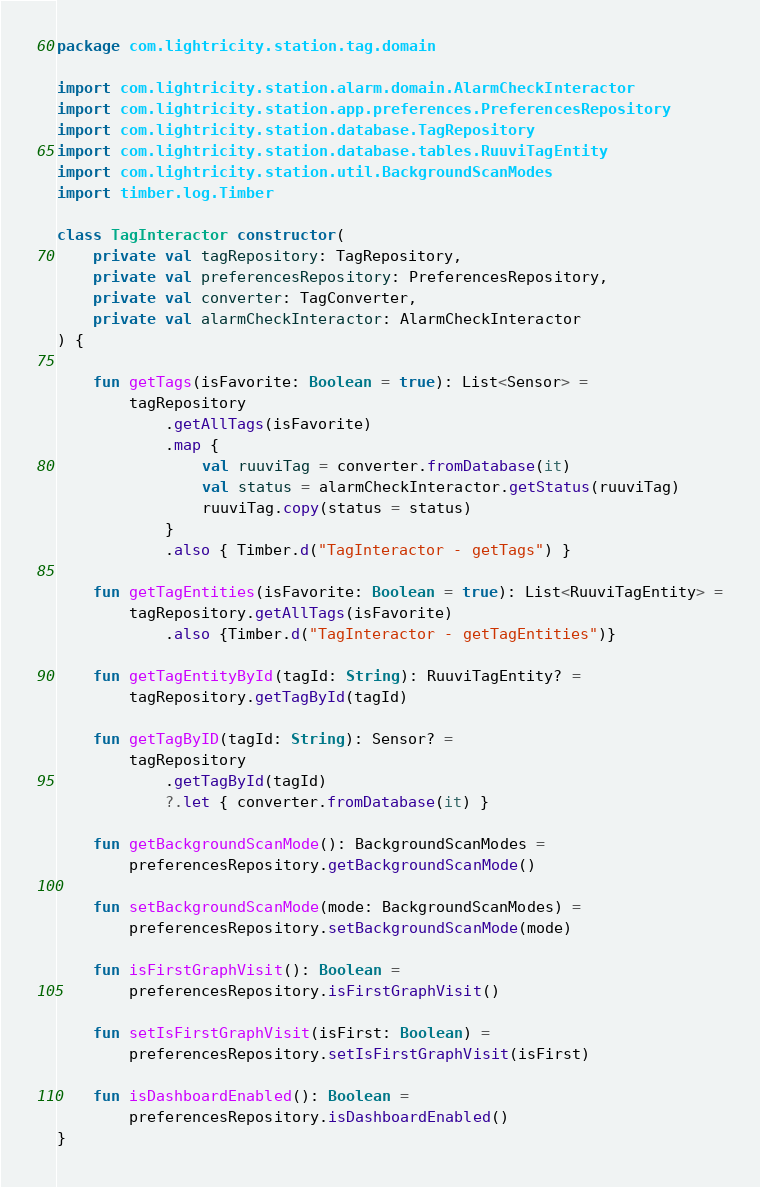Convert code to text. <code><loc_0><loc_0><loc_500><loc_500><_Kotlin_>package com.lightricity.station.tag.domain

import com.lightricity.station.alarm.domain.AlarmCheckInteractor
import com.lightricity.station.app.preferences.PreferencesRepository
import com.lightricity.station.database.TagRepository
import com.lightricity.station.database.tables.RuuviTagEntity
import com.lightricity.station.util.BackgroundScanModes
import timber.log.Timber

class TagInteractor constructor(
    private val tagRepository: TagRepository,
    private val preferencesRepository: PreferencesRepository,
    private val converter: TagConverter,
    private val alarmCheckInteractor: AlarmCheckInteractor
) {

    fun getTags(isFavorite: Boolean = true): List<Sensor> =
        tagRepository
            .getAllTags(isFavorite)
            .map {
                val ruuviTag = converter.fromDatabase(it)
                val status = alarmCheckInteractor.getStatus(ruuviTag)
                ruuviTag.copy(status = status)
            }
            .also { Timber.d("TagInteractor - getTags") }

    fun getTagEntities(isFavorite: Boolean = true): List<RuuviTagEntity> =
        tagRepository.getAllTags(isFavorite)
            .also {Timber.d("TagInteractor - getTagEntities")}

    fun getTagEntityById(tagId: String): RuuviTagEntity? =
        tagRepository.getTagById(tagId)

    fun getTagByID(tagId: String): Sensor? =
        tagRepository
            .getTagById(tagId)
            ?.let { converter.fromDatabase(it) }

    fun getBackgroundScanMode(): BackgroundScanModes =
        preferencesRepository.getBackgroundScanMode()

    fun setBackgroundScanMode(mode: BackgroundScanModes) =
        preferencesRepository.setBackgroundScanMode(mode)

    fun isFirstGraphVisit(): Boolean =
        preferencesRepository.isFirstGraphVisit()

    fun setIsFirstGraphVisit(isFirst: Boolean) =
        preferencesRepository.setIsFirstGraphVisit(isFirst)

    fun isDashboardEnabled(): Boolean =
        preferencesRepository.isDashboardEnabled()
}</code> 